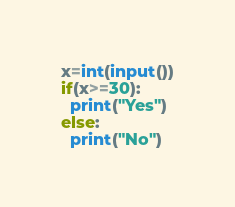<code> <loc_0><loc_0><loc_500><loc_500><_Python_>x=int(input())
if(x>=30):
  print("Yes")
else:
  print("No")</code> 